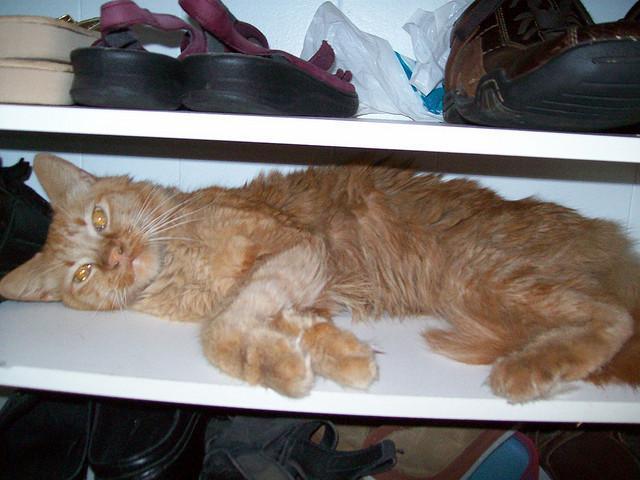How many giraffes are there?
Give a very brief answer. 0. 